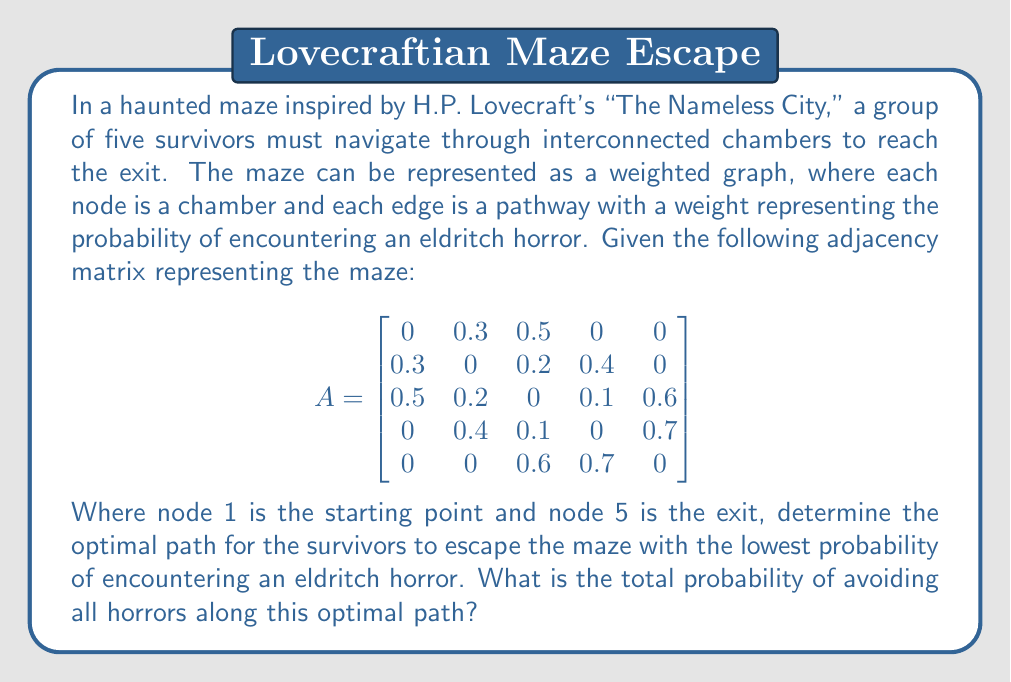Help me with this question. To solve this problem, we need to find the path from node 1 to node 5 that minimizes the probability of encountering horrors. Since the weights represent the probability of encountering a horror, we want to maximize the probability of avoiding horrors along the path.

1. First, we need to convert the given probabilities to represent the chance of avoiding horrors:
   For each edge $(i,j)$, we calculate $1 - A_{ij}$

2. The new adjacency matrix becomes:
   $$
   A' = \begin{bmatrix}
   1 & 0.7 & 0.5 & 1 & 1 \\
   0.7 & 1 & 0.8 & 0.6 & 1 \\
   0.5 & 0.8 & 1 & 0.9 & 0.4 \\
   1 & 0.6 & 0.9 & 1 & 0.3 \\
   1 & 1 & 0.4 & 0.3 & 1
   \end{bmatrix}
   $$

3. Now, we need to find the path that maximizes the product of these probabilities. This is equivalent to finding the shortest path in a graph where the edge weights are the negative logarithms of these probabilities.

4. We apply the transformation: $w_{ij} = -\log(A'_{ij})$

5. The resulting weighted graph becomes:
   $$
   W = \begin{bmatrix}
   0 & 0.3567 & 0.6931 & 0 & 0 \\
   0.3567 & 0 & 0.2231 & 0.5108 & 0 \\
   0.6931 & 0.2231 & 0 & 0.1054 & 0.9163 \\
   0 & 0.5108 & 0.1054 & 0 & 1.2040 \\
   0 & 0 & 0.9163 & 1.2040 & 0
   \end{bmatrix}
   $$

6. Now we can apply Dijkstra's algorithm to find the shortest path from node 1 to node 5:
   
   1 → 2 → 3 → 4 → 5

7. The total weight of this path is:
   $0.3567 + 0.2231 + 0.1054 + 1.2040 = 1.8892$

8. To get the final probability of avoiding all horrors, we calculate:
   $e^{-1.8892} = 0.1512$

Therefore, the optimal path is 1 → 2 → 3 → 4 → 5, and the probability of avoiding all horrors along this path is approximately 0.1512 or 15.12%.
Answer: The optimal path is 1 → 2 → 3 → 4 → 5, and the probability of avoiding all horrors along this path is approximately 0.1512 or 15.12%. 